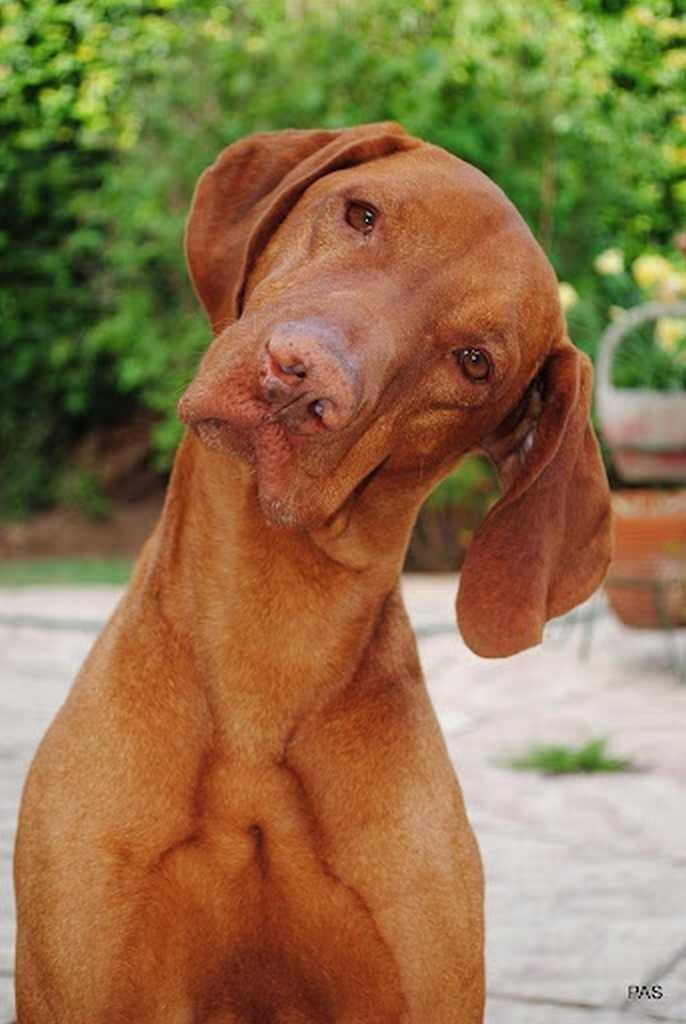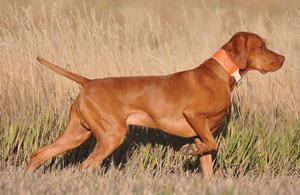The first image is the image on the left, the second image is the image on the right. Considering the images on both sides, is "The dog in one of the images is lying down on the grass." valid? Answer yes or no. No. 